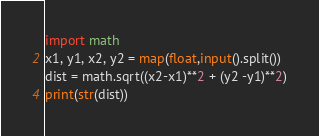Convert code to text. <code><loc_0><loc_0><loc_500><loc_500><_Python_>import math
x1, y1, x2, y2 = map(float,input().split())
dist = math.sqrt((x2-x1)**2 + (y2 -y1)**2)
print(str(dist))
</code> 